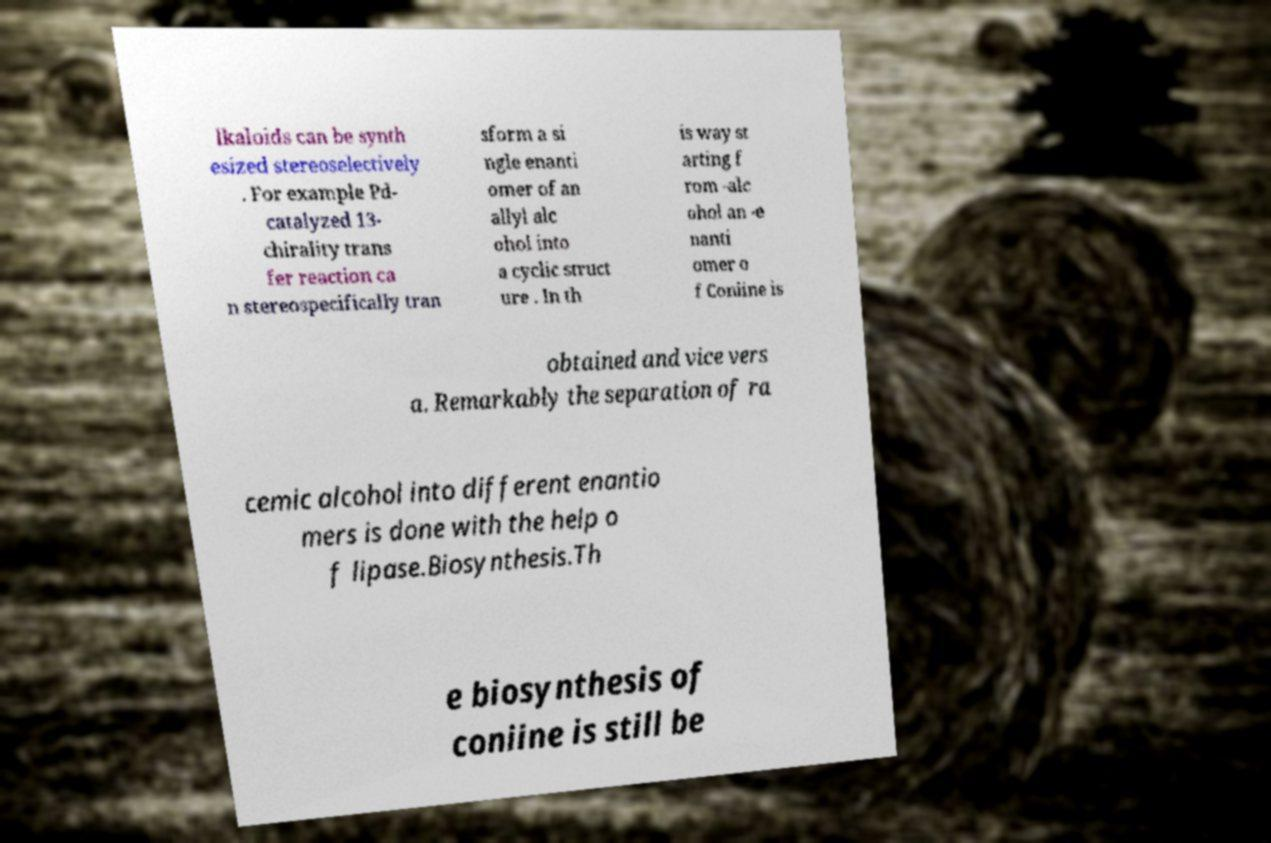Please read and relay the text visible in this image. What does it say? lkaloids can be synth esized stereoselectively . For example Pd- catalyzed 13- chirality trans fer reaction ca n stereospecifically tran sform a si ngle enanti omer of an allyl alc ohol into a cyclic struct ure . In th is way st arting f rom -alc ohol an -e nanti omer o f Coniine is obtained and vice vers a. Remarkably the separation of ra cemic alcohol into different enantio mers is done with the help o f lipase.Biosynthesis.Th e biosynthesis of coniine is still be 